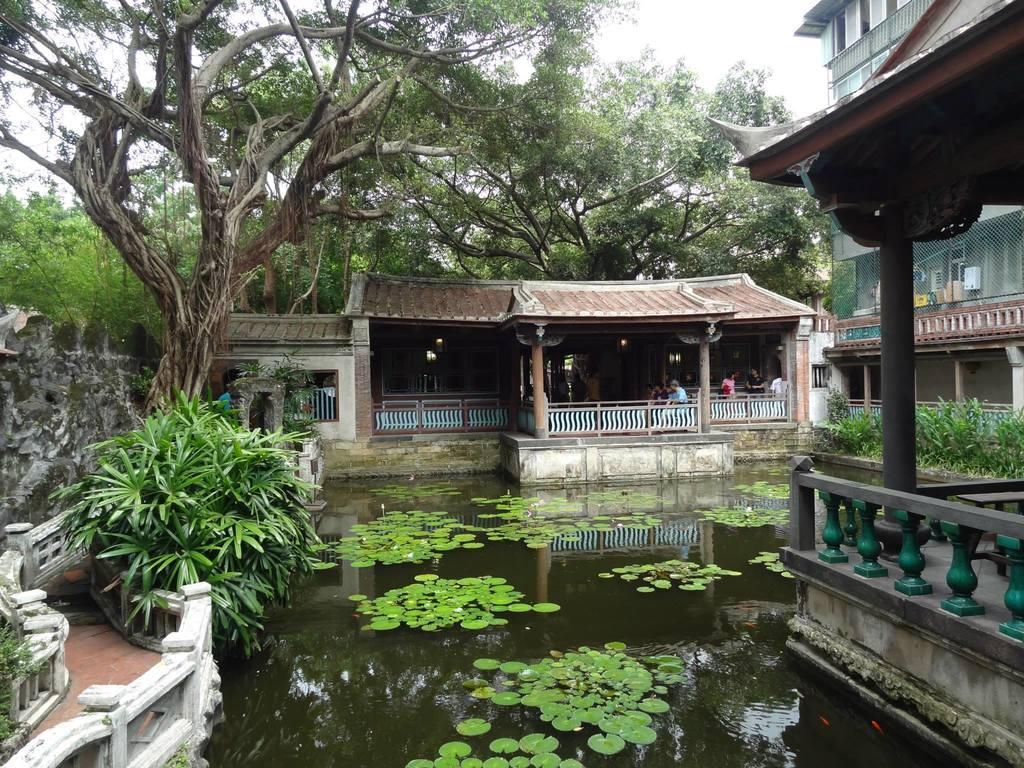What type of vegetation can be seen in the image? There are trees in the image. What type of structures are present in the image? There are houses in the image. What natural element is visible in the image? Water is visible in the image. What is visible in the background of the image? The sky is visible in the image. Can you see any thrill in the image? There is no thrill present in the image; it is a scene featuring trees, houses, water, and the sky. Are there any fangs visible in the image? There are no fangs present in the image. 